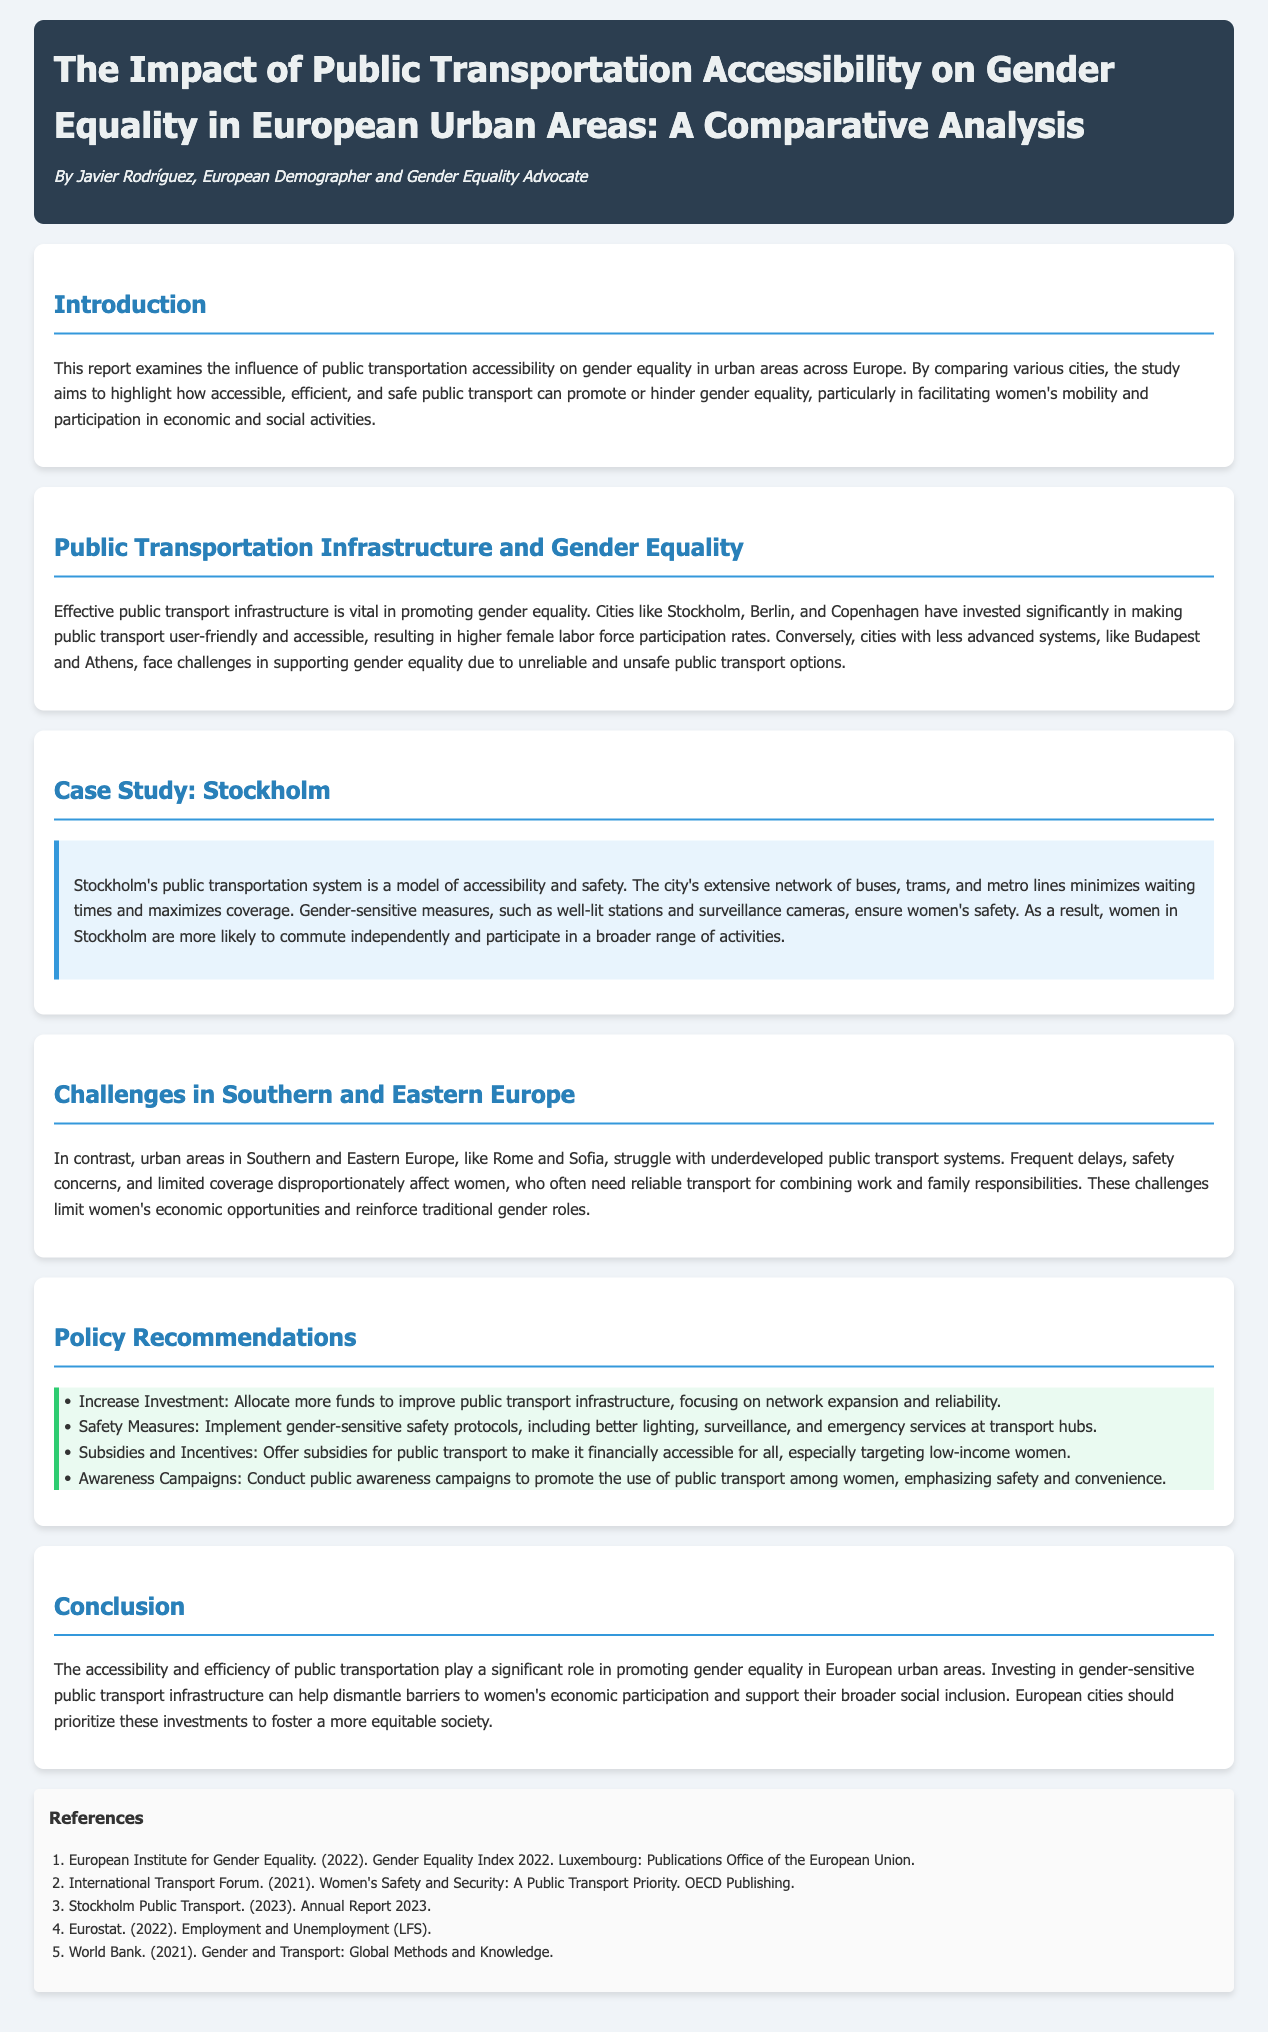What is the main focus of the report? The report examines the influence of public transportation accessibility on gender equality in urban areas across Europe.
Answer: Influence of public transportation accessibility on gender equality Which cities are highlighted for their effective public transport infrastructure? The report mentions cities like Stockholm, Berlin, and Copenhagen as having significant investments in public transport.
Answer: Stockholm, Berlin, Copenhagen What are some challenges faced in Southern and Eastern Europe? The report identifies frequent delays, safety concerns, and limited coverage as challenges in Southern and Eastern Europe.
Answer: Frequent delays, safety concerns, limited coverage Which city serves as a case study for public transportation accessibility? Stockholm is cited as a model for accessibility and safety in public transport within the report.
Answer: Stockholm What type of measures does the report suggest to improve safety in public transport? Gender-sensitive safety protocols such as better lighting and surveillance are recommended in the report.
Answer: Gender-sensitive safety protocols What percentage of the report's policy recommendations focuses on investment? The first recommendation advocates for increased investment in public transport infrastructure.
Answer: Increased investment How does the report suggest targeting low-income women? It proposes offering subsidies for public transport to make it financially accessible for low-income women.
Answer: Subsidies for public transport What is one outcome of Stockholm's public transportation system? Women in Stockholm are more likely to commute independently and participate in a broader range of activities.
Answer: More likely to commute independently What does the report conclude about public transportation's role? The conclusion states that public transportation accessibility significantly impacts gender equality in urban areas.
Answer: Significant impact on gender equality 